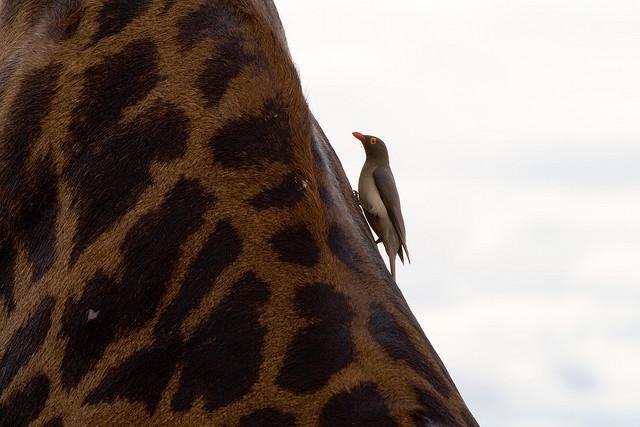Is this bird looking up?
Write a very short answer. Yes. What does it look like the bird is resting on?
Write a very short answer. Giraffe. What color is the bird's beak?
Write a very short answer. Orange. 